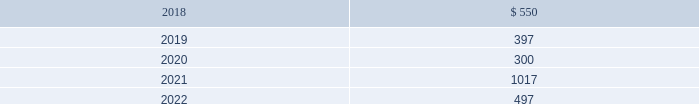In january 2016 , the company issued $ 800 million of debt securities consisting of a $ 400 million aggregate principal three year fixed rate note with a coupon rate of 2.00% ( 2.00 % ) and a $ 400 million aggregate principal seven year fixed rate note with a coupon rate of 3.25% ( 3.25 % ) .
The proceeds were used to repay a portion of the company 2019s outstanding commercial paper , repay the remaining term loan balance , and for general corporate purposes .
The company 2019s public notes and 144a notes may be redeemed by the company at its option at redemption prices that include accrued and unpaid interest and a make-whole premium .
Upon the occurrence of a change of control accompanied by a downgrade of the notes below investment grade rating , within a specified time period , the company would be required to offer to repurchase the public notes and 144a notes at a price equal to 101% ( 101 % ) of the aggregate principal amount thereof , plus any accrued and unpaid interest to the date of repurchase .
The public notes and 144a notes are senior unsecured and unsubordinated obligations of the company and rank equally with all other senior and unsubordinated indebtedness of the company .
The company entered into a registration rights agreement in connection with the issuance of the 144a notes .
Subject to certain limitations set forth in the registration rights agreement , the company has agreed to ( i ) file a registration statement ( the 201cexchange offer registration statement 201d ) with respect to registered offers to exchange the 144a notes for exchange notes ( the 201cexchange notes 201d ) , which will have terms identical in all material respects to the new 10-year notes and new 30-year notes , as applicable , except that the exchange notes will not contain transfer restrictions and will not provide for any increase in the interest rate thereon in certain circumstances and ( ii ) use commercially reasonable efforts to cause the exchange offer registration statement to be declared effective within 270 days after the date of issuance of the 144a notes .
Until such time as the exchange offer registration statement is declared effective , the 144a notes may only be sold in accordance with rule 144a or regulation s of the securities act of 1933 , as amended .
Private notes the company 2019s private notes may be redeemed by the company at its option at redemption prices that include accrued and unpaid interest and a make-whole premium .
Upon the occurrence of specified changes of control involving the company , the company would be required to offer to repurchase the private notes at a price equal to 100% ( 100 % ) of the aggregate principal amount thereof , plus any accrued and unpaid interest to the date of repurchase .
Additionally , the company would be required to make a similar offer to repurchase the private notes upon the occurrence of specified merger events or asset sales involving the company , when accompanied by a downgrade of the private notes below investment grade rating , within a specified time period .
The private notes are unsecured senior obligations of the company and rank equal in right of payment with all other senior indebtedness of the company .
The private notes shall be unconditionally guaranteed by subsidiaries of the company in certain circumstances , as described in the note purchase agreements as amended .
Other debt during 2015 , the company acquired the beneficial interest in the trust owning the leased naperville facility resulting in debt assumption of $ 100.2 million and the addition of $ 135.2 million in property , plant and equipment .
Certain administrative , divisional , and research and development personnel are based at the naperville facility .
Cash paid as a result of the transaction was $ 19.8 million .
The assumption of debt and the majority of the property , plant and equipment addition represented non-cash financing and investing activities , respectively .
The remaining balance on the assumed debt was settled in december 2017 and was reflected in the "other" line of the table above at december 31 , 2016 .
Covenants and future maturities the company is in compliance with all covenants under the company 2019s outstanding indebtedness at december 31 , 2017 .
As of december 31 , 2017 , the aggregate annual maturities of long-term debt for the next five years were : ( millions ) .

When the company acquired the beneficial interest in the trust owning the leased naperville facility , the cash paid was what percentage of property , plant and equipment?\\n\\n[7] : certain administrative , divisional , and research and development personnel are based at the naperville facility.\\n\\n[8] : cash paid as a result of the transaction was $ 19.8 millio? 
Computations: (19.8 / 135.2)
Answer: 0.14645. 